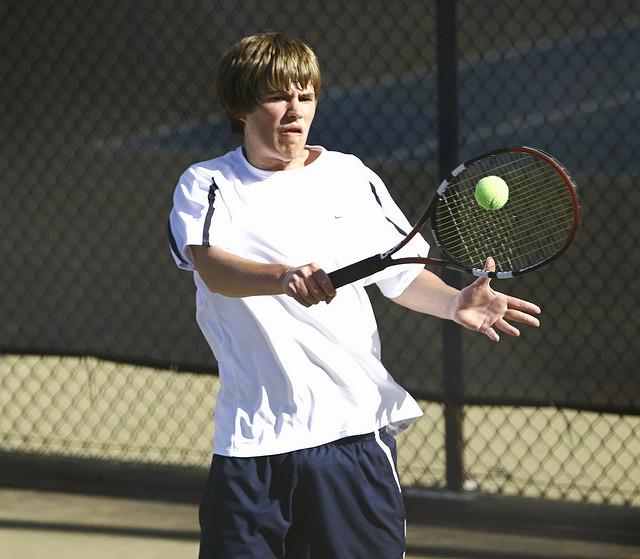Is the ball floating right next to his face?
Be succinct. No. Is the guy all sweaty?
Keep it brief. No. What color is the handle of the tennis racket?
Short answer required. Black. Is the arm wearing a wristband?
Give a very brief answer. No. Do you think he knows what he is doing?
Concise answer only. Yes. What color is his tennis racket?
Concise answer only. Black. Is the player male or female?
Answer briefly. Male. 